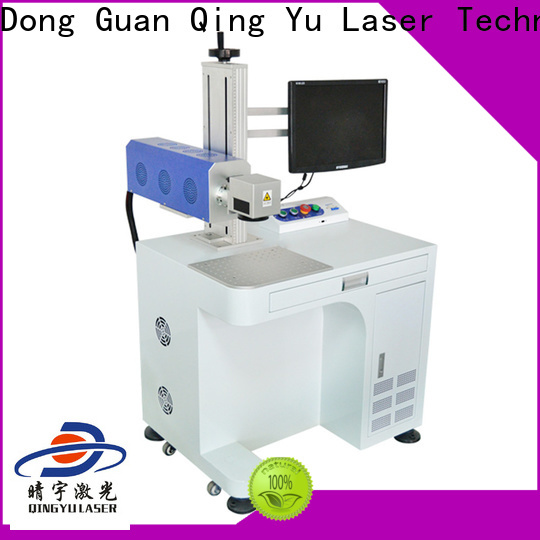If this machine was sent to space, what unique tasks could it perform to benefit a space mission? Imagine this laser engraving machine on a space mission to a Mars colony. It could be used for several critical, innovative tasks. First, it could engrave important identifiers and labels on tools and equipment to ensure easy identification and organization in the space station’s zero-gravity environment. Additionally, the machine could be valuable for marking scientific instruments with precise calibration indicators, which is crucial for conducting accurate experiments. In a scenario where astronauts need to fabricate or repair parts using materials available on Mars, the engraving machine could add necessary instructions or assembly guides directly onto these parts. Moreover, it could contribute to morale and team spirit by creating personalized engraved items for the crew, serving as a reminder of their unique journey through space. The immense precision and versatility of the laser engraver make it a critical tool for the uncharted challenges of space exploration. 